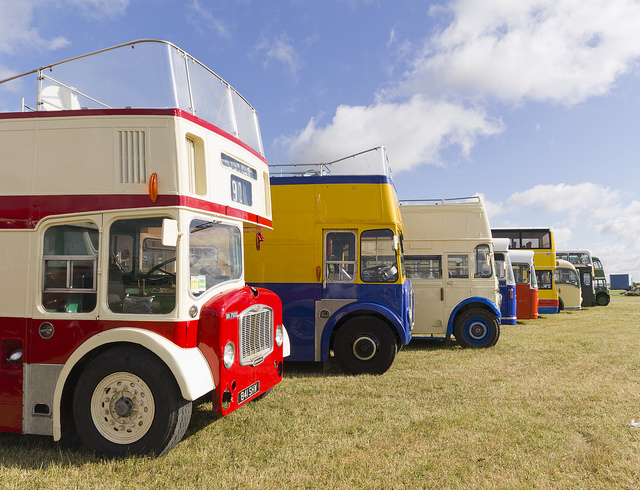Identify the text displayed in this image. BUS 92 